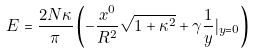Convert formula to latex. <formula><loc_0><loc_0><loc_500><loc_500>E = \frac { 2 N \kappa } { \pi } \left ( - \frac { x ^ { 0 } } { R ^ { 2 } } { \sqrt { 1 + \kappa ^ { 2 } } } + \gamma \frac { 1 } { y } | _ { y = 0 } \right )</formula> 